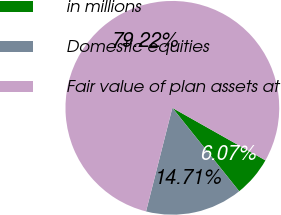Convert chart to OTSL. <chart><loc_0><loc_0><loc_500><loc_500><pie_chart><fcel>in millions<fcel>Domestic equities<fcel>Fair value of plan assets at<nl><fcel>6.07%<fcel>14.71%<fcel>79.22%<nl></chart> 